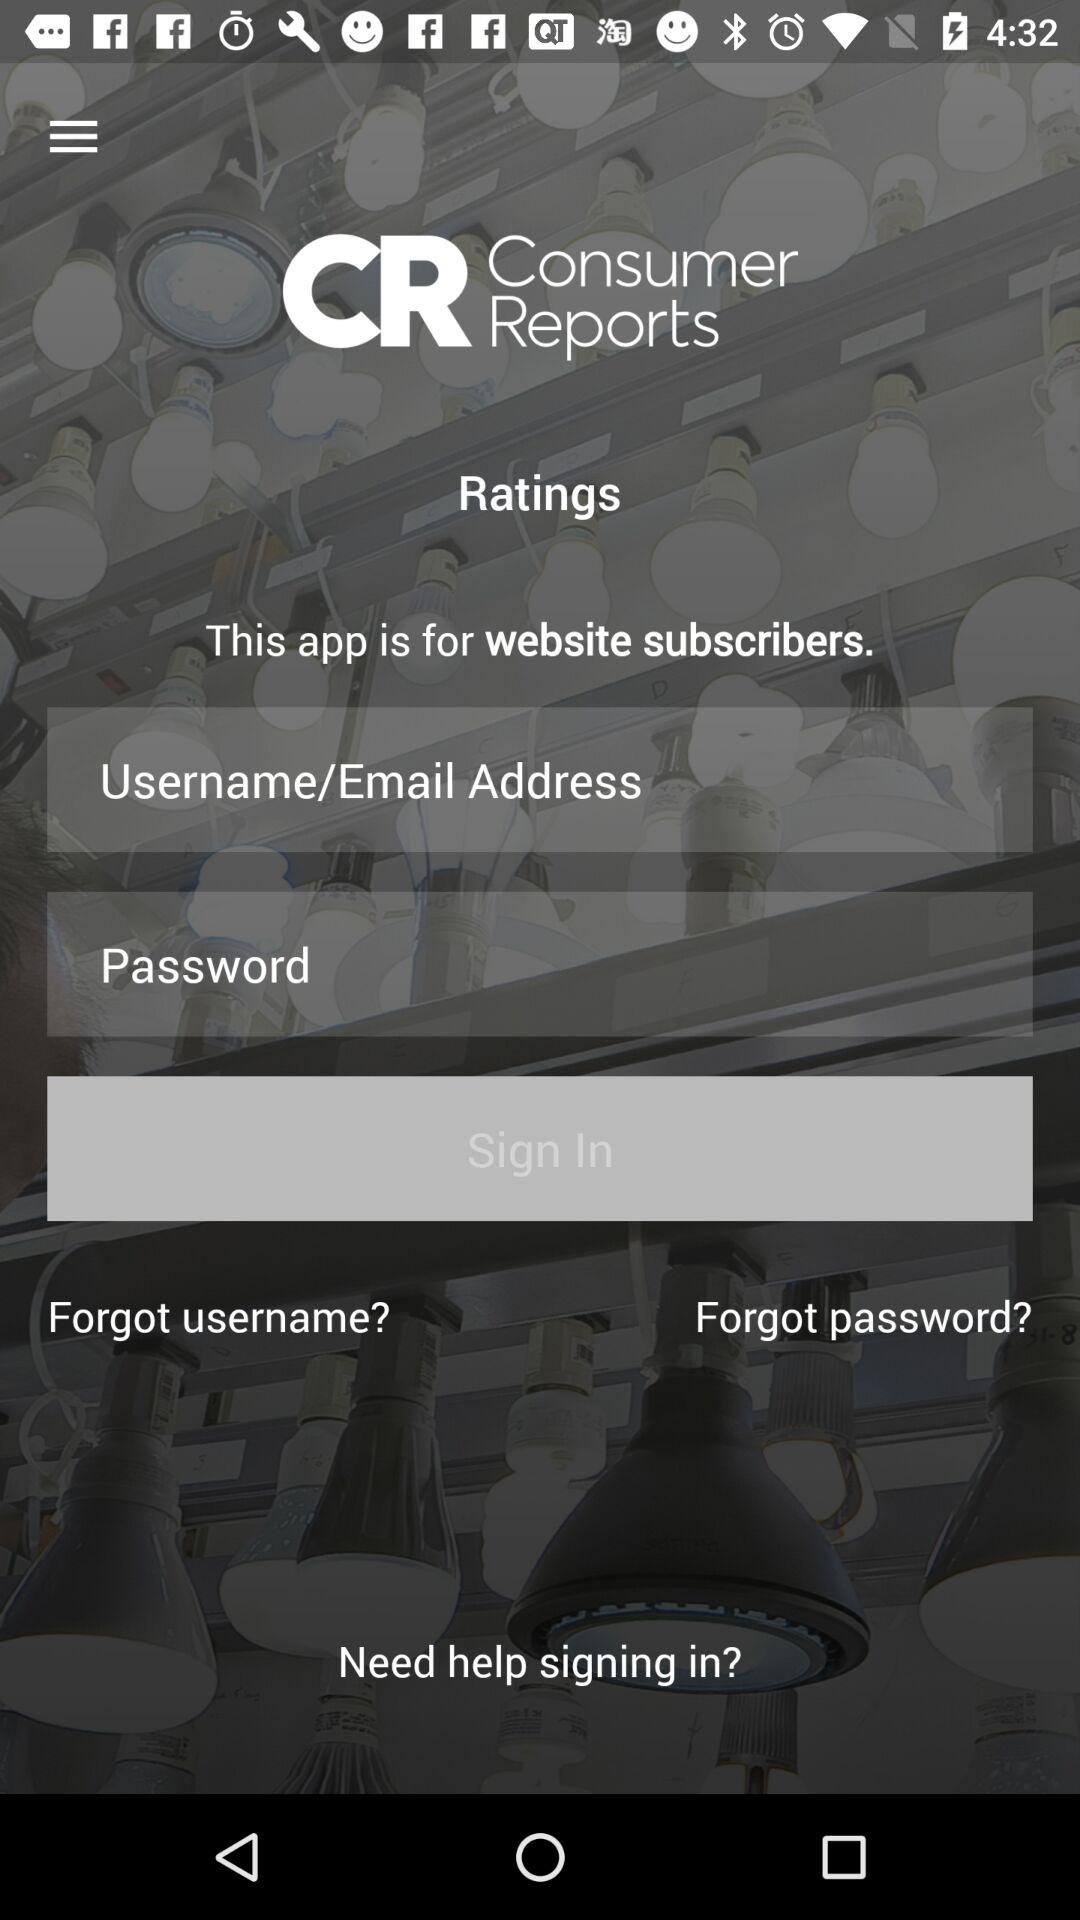How many text inputs are in the sign-in form? The sign-in form contains two text inputs for user authentication: one for the Username/Email Address and another for the Password. 